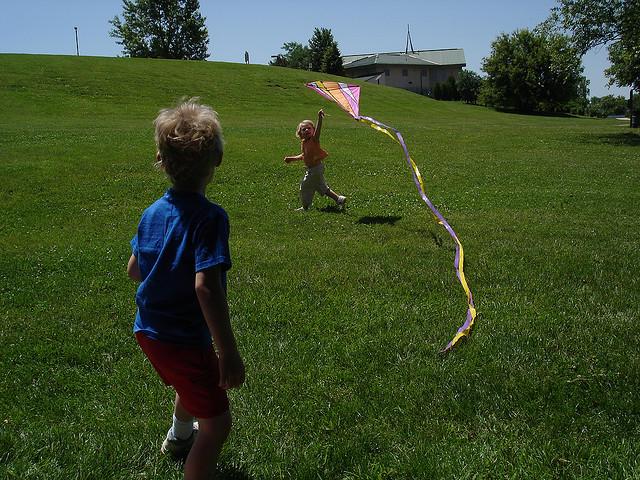What are the people playing with?
Answer briefly. Kite. What is flying?
Keep it brief. Kite. Are they playing Frisbee?
Short answer required. No. Should someone help her with the launching?
Answer briefly. Yes. What is the prone man holding?
Short answer required. Kite. How many kids?
Give a very brief answer. 2. What is he throwing?
Give a very brief answer. Kite. How is the kite designed?
Short answer required. Long. How many adults are in the picture?
Answer briefly. 0. Is the grass extremely green?
Quick response, please. Yes. Is the kid old enough to swing on the swing set without an adult?
Write a very short answer. Yes. Are a lot of people flying kites in the same area as the girl?
Answer briefly. No. Are they going to fight over who gets to use it next?
Answer briefly. Yes. Is this a cloudy day?
Concise answer only. No. How many cows are in the picture?
Answer briefly. 0. What's the thing flying through the air?
Be succinct. Kite. What color is the kite's tail?
Short answer required. Purple and yellow. Is the child's hair blonde?
Give a very brief answer. Yes. What are the people doing in the front yard?
Keep it brief. Flying kite. Is this setting natural or is it cultivated?
Quick response, please. Cultivated. What is the woman about to throw?
Give a very brief answer. Nothing. Which child holds the kite?
Be succinct. Girl. What is the girl throwing?
Keep it brief. Kite. 